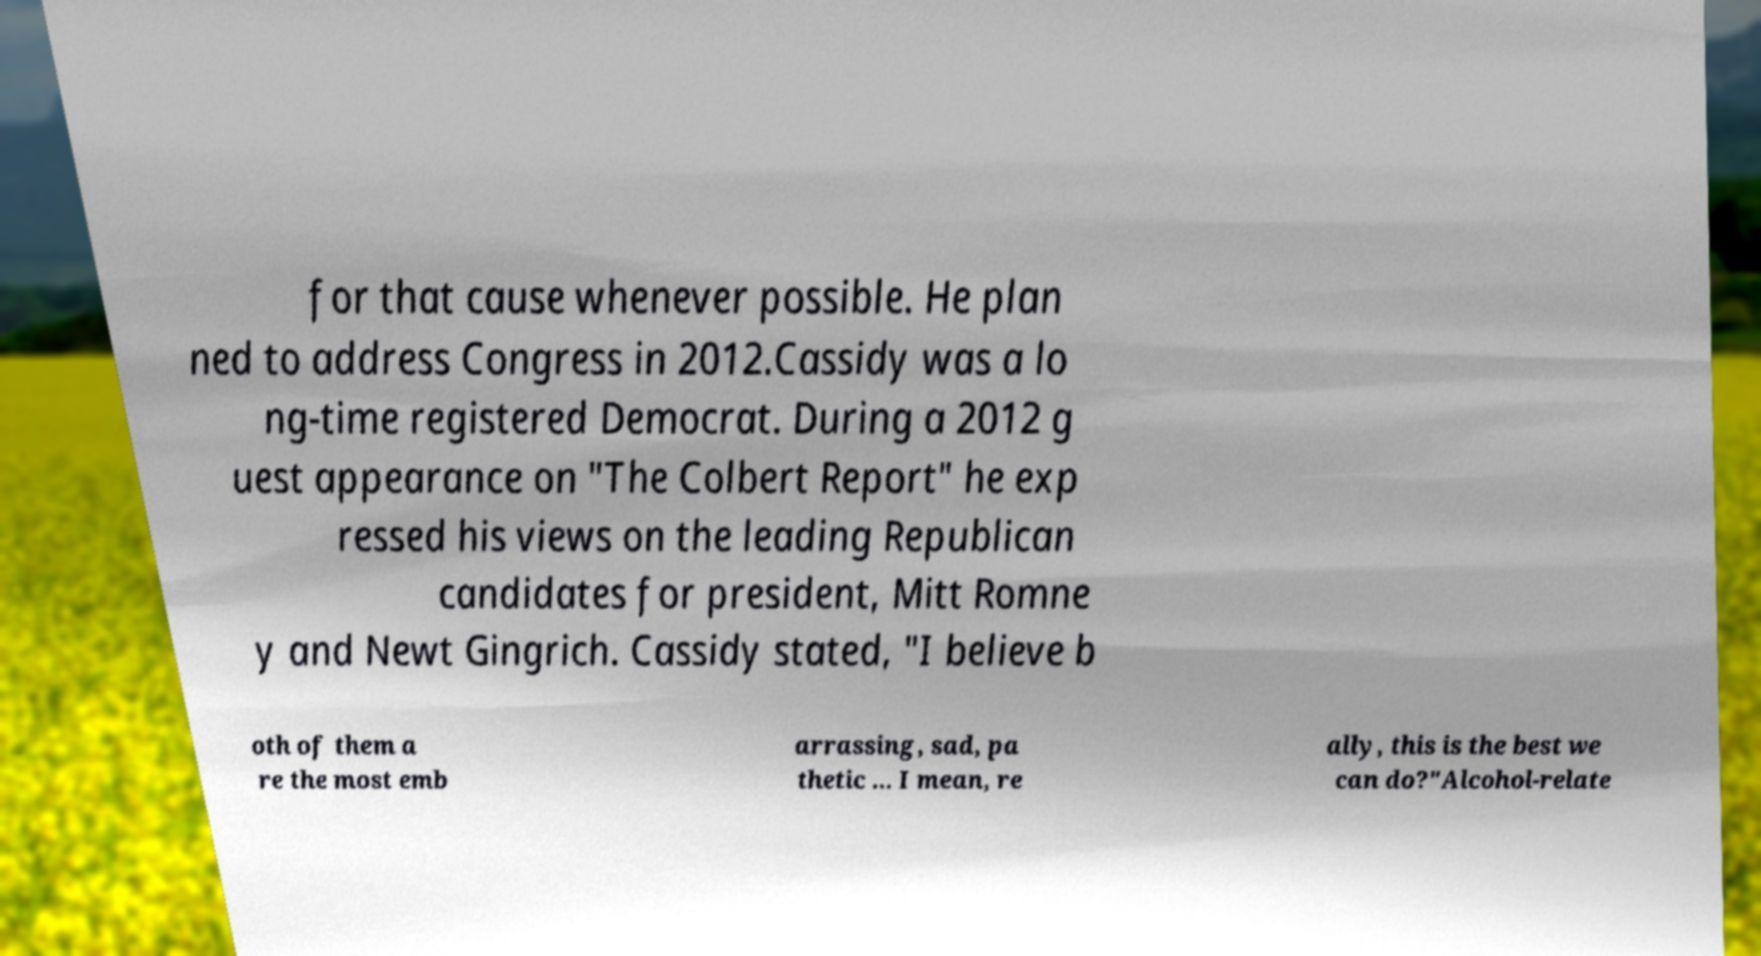Please identify and transcribe the text found in this image. for that cause whenever possible. He plan ned to address Congress in 2012.Cassidy was a lo ng-time registered Democrat. During a 2012 g uest appearance on "The Colbert Report" he exp ressed his views on the leading Republican candidates for president, Mitt Romne y and Newt Gingrich. Cassidy stated, "I believe b oth of them a re the most emb arrassing, sad, pa thetic ... I mean, re ally, this is the best we can do?"Alcohol-relate 